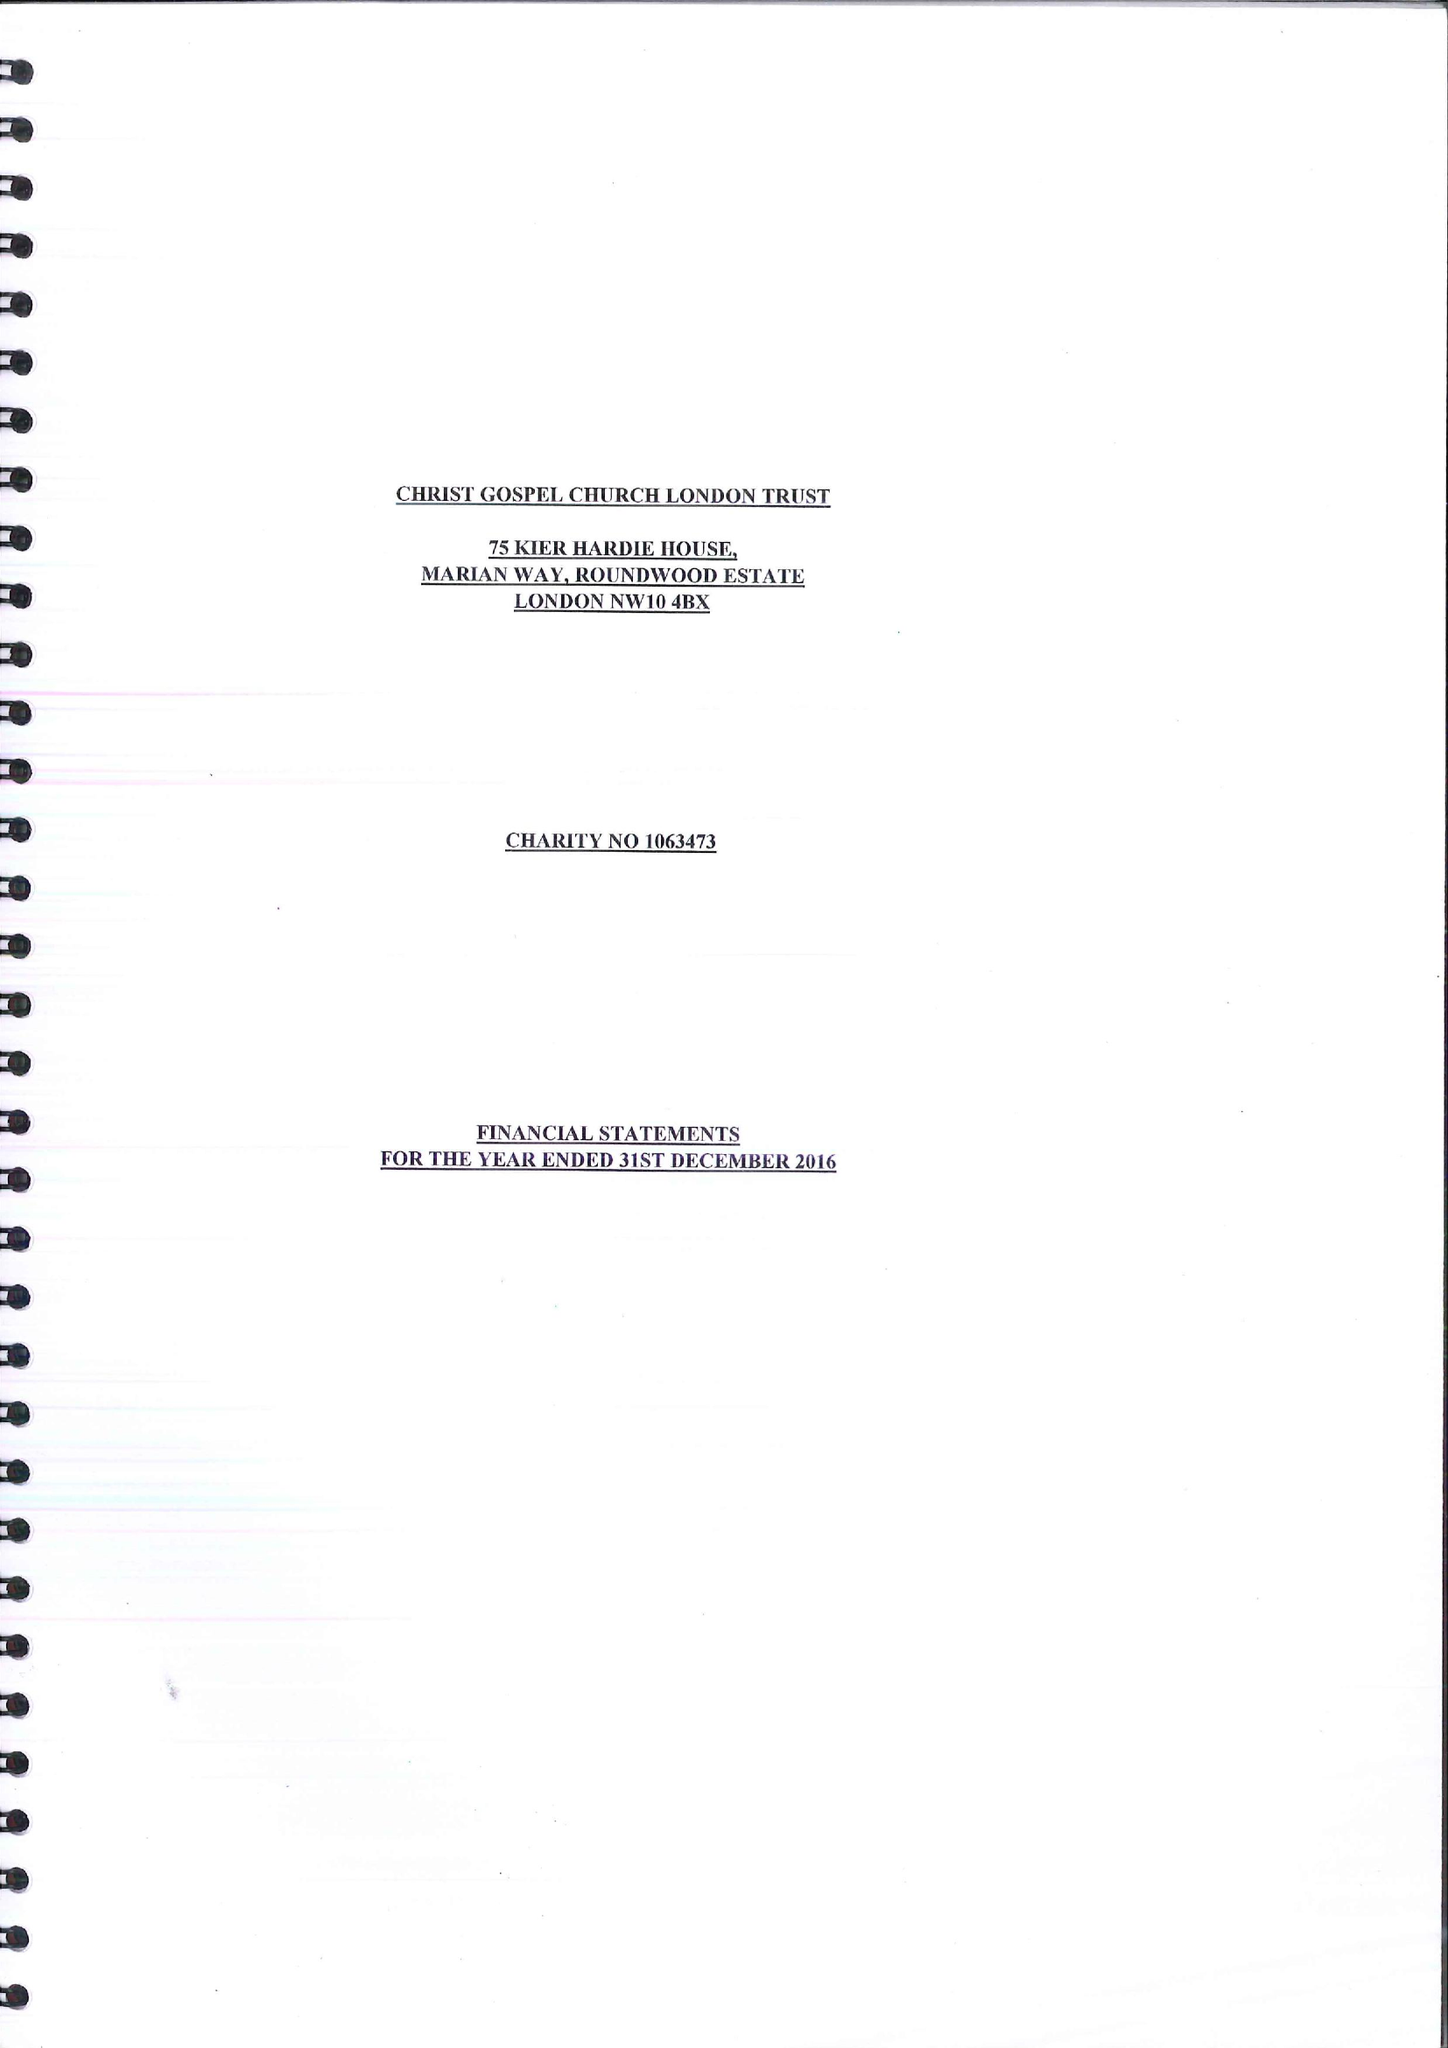What is the value for the charity_number?
Answer the question using a single word or phrase. 1063473 